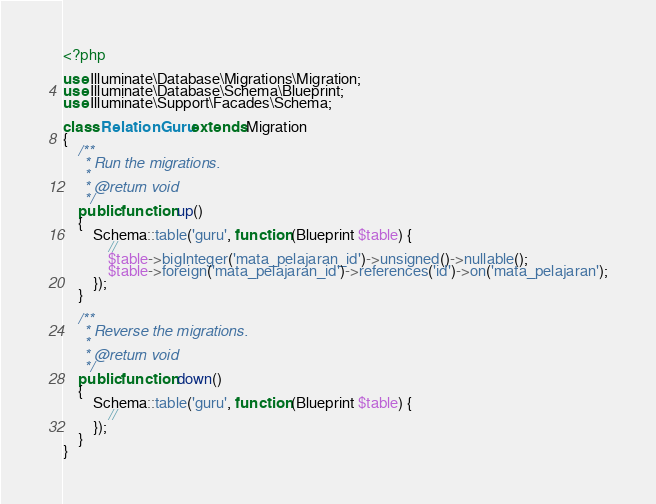Convert code to text. <code><loc_0><loc_0><loc_500><loc_500><_PHP_><?php

use Illuminate\Database\Migrations\Migration;
use Illuminate\Database\Schema\Blueprint;
use Illuminate\Support\Facades\Schema;

class RelationGuru extends Migration
{
    /**
     * Run the migrations.
     *
     * @return void
     */
    public function up()
    {
        Schema::table('guru', function (Blueprint $table) {
            //
            $table->bigInteger('mata_pelajaran_id')->unsigned()->nullable();
            $table->foreign('mata_pelajaran_id')->references('id')->on('mata_pelajaran');
        });
    }

    /**
     * Reverse the migrations.
     *
     * @return void
     */
    public function down()
    {
        Schema::table('guru', function (Blueprint $table) {
            //
        });
    }
}
</code> 